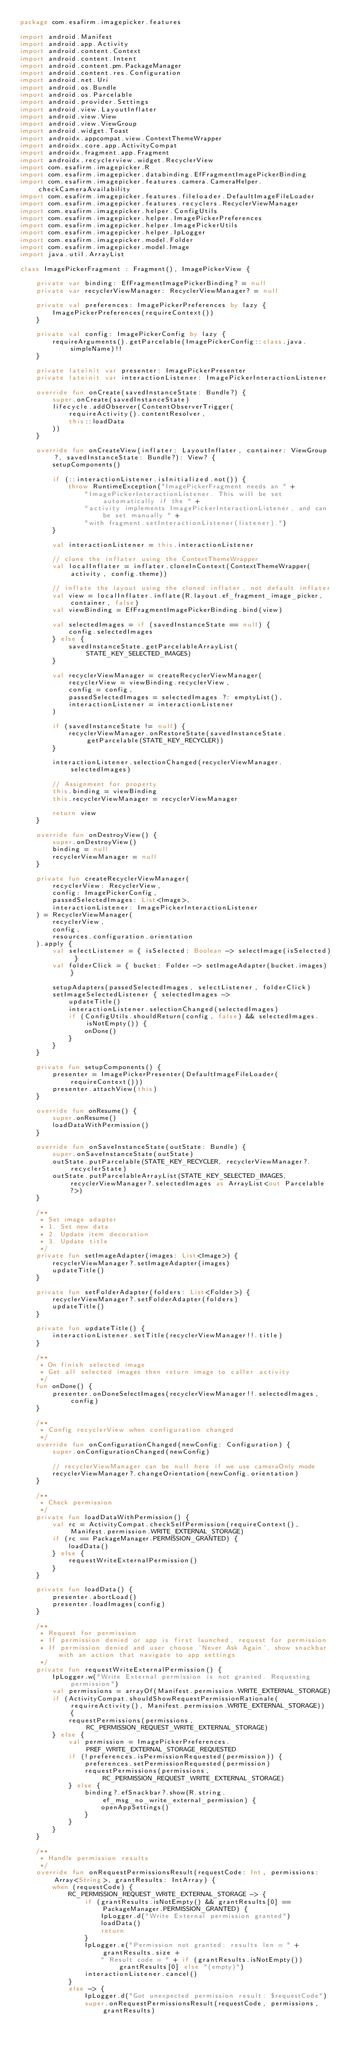<code> <loc_0><loc_0><loc_500><loc_500><_Kotlin_>package com.esafirm.imagepicker.features

import android.Manifest
import android.app.Activity
import android.content.Context
import android.content.Intent
import android.content.pm.PackageManager
import android.content.res.Configuration
import android.net.Uri
import android.os.Bundle
import android.os.Parcelable
import android.provider.Settings
import android.view.LayoutInflater
import android.view.View
import android.view.ViewGroup
import android.widget.Toast
import androidx.appcompat.view.ContextThemeWrapper
import androidx.core.app.ActivityCompat
import androidx.fragment.app.Fragment
import androidx.recyclerview.widget.RecyclerView
import com.esafirm.imagepicker.R
import com.esafirm.imagepicker.databinding.EfFragmentImagePickerBinding
import com.esafirm.imagepicker.features.camera.CameraHelper.checkCameraAvailability
import com.esafirm.imagepicker.features.fileloader.DefaultImageFileLoader
import com.esafirm.imagepicker.features.recyclers.RecyclerViewManager
import com.esafirm.imagepicker.helper.ConfigUtils
import com.esafirm.imagepicker.helper.ImagePickerPreferences
import com.esafirm.imagepicker.helper.ImagePickerUtils
import com.esafirm.imagepicker.helper.IpLogger
import com.esafirm.imagepicker.model.Folder
import com.esafirm.imagepicker.model.Image
import java.util.ArrayList

class ImagePickerFragment : Fragment(), ImagePickerView {

    private var binding: EfFragmentImagePickerBinding? = null
    private var recyclerViewManager: RecyclerViewManager? = null

    private val preferences: ImagePickerPreferences by lazy {
        ImagePickerPreferences(requireContext())
    }

    private val config: ImagePickerConfig by lazy {
        requireArguments().getParcelable(ImagePickerConfig::class.java.simpleName)!!
    }

    private lateinit var presenter: ImagePickerPresenter
    private lateinit var interactionListener: ImagePickerInteractionListener

    override fun onCreate(savedInstanceState: Bundle?) {
        super.onCreate(savedInstanceState)
        lifecycle.addObserver(ContentObserverTrigger(
            requireActivity().contentResolver,
            this::loadData
        ))
    }

    override fun onCreateView(inflater: LayoutInflater, container: ViewGroup?, savedInstanceState: Bundle?): View? {
        setupComponents()

        if (::interactionListener.isInitialized.not()) {
            throw RuntimeException("ImagePickerFragment needs an " +
                "ImagePickerInteractionListener. This will be set automatically if the " +
                "activity implements ImagePickerInteractionListener, and can be set manually " +
                "with fragment.setInteractionListener(listener).")
        }

        val interactionListener = this.interactionListener

        // clone the inflater using the ContextThemeWrapper
        val localInflater = inflater.cloneInContext(ContextThemeWrapper(activity, config.theme))

        // inflate the layout using the cloned inflater, not default inflater
        val view = localInflater.inflate(R.layout.ef_fragment_image_picker, container, false)
        val viewBinding = EfFragmentImagePickerBinding.bind(view)

        val selectedImages = if (savedInstanceState == null) {
            config.selectedImages
        } else {
            savedInstanceState.getParcelableArrayList(STATE_KEY_SELECTED_IMAGES)
        }

        val recyclerViewManager = createRecyclerViewManager(
            recyclerView = viewBinding.recyclerView,
            config = config,
            passedSelectedImages = selectedImages ?: emptyList(),
            interactionListener = interactionListener
        )

        if (savedInstanceState != null) {
            recyclerViewManager.onRestoreState(savedInstanceState.getParcelable(STATE_KEY_RECYCLER))
        }

        interactionListener.selectionChanged(recyclerViewManager.selectedImages)

        // Assignment for property
        this.binding = viewBinding
        this.recyclerViewManager = recyclerViewManager

        return view
    }

    override fun onDestroyView() {
        super.onDestroyView()
        binding = null
        recyclerViewManager = null
    }

    private fun createRecyclerViewManager(
        recyclerView: RecyclerView,
        config: ImagePickerConfig,
        passedSelectedImages: List<Image>,
        interactionListener: ImagePickerInteractionListener
    ) = RecyclerViewManager(
        recyclerView,
        config,
        resources.configuration.orientation
    ).apply {
        val selectListener = { isSelected: Boolean -> selectImage(isSelected) }
        val folderClick = { bucket: Folder -> setImageAdapter(bucket.images) }

        setupAdapters(passedSelectedImages, selectListener, folderClick)
        setImageSelectedListener { selectedImages ->
            updateTitle()
            interactionListener.selectionChanged(selectedImages)
            if (ConfigUtils.shouldReturn(config, false) && selectedImages.isNotEmpty()) {
                onDone()
            }
        }
    }

    private fun setupComponents() {
        presenter = ImagePickerPresenter(DefaultImageFileLoader(requireContext()))
        presenter.attachView(this)
    }

    override fun onResume() {
        super.onResume()
        loadDataWithPermission()
    }

    override fun onSaveInstanceState(outState: Bundle) {
        super.onSaveInstanceState(outState)
        outState.putParcelable(STATE_KEY_RECYCLER, recyclerViewManager?.recyclerState)
        outState.putParcelableArrayList(STATE_KEY_SELECTED_IMAGES, recyclerViewManager?.selectedImages as ArrayList<out Parcelable?>)
    }

    /**
     * Set image adapter
     * 1. Set new data
     * 2. Update item decoration
     * 3. Update title
     */
    private fun setImageAdapter(images: List<Image>) {
        recyclerViewManager?.setImageAdapter(images)
        updateTitle()
    }

    private fun setFolderAdapter(folders: List<Folder>) {
        recyclerViewManager?.setFolderAdapter(folders)
        updateTitle()
    }

    private fun updateTitle() {
        interactionListener.setTitle(recyclerViewManager!!.title)
    }

    /**
     * On finish selected image
     * Get all selected images then return image to caller activity
     */
    fun onDone() {
        presenter.onDoneSelectImages(recyclerViewManager!!.selectedImages, config)
    }

    /**
     * Config recyclerView when configuration changed
     */
    override fun onConfigurationChanged(newConfig: Configuration) {
        super.onConfigurationChanged(newConfig)

        // recyclerViewManager can be null here if we use cameraOnly mode
        recyclerViewManager?.changeOrientation(newConfig.orientation)
    }

    /**
     * Check permission
     */
    private fun loadDataWithPermission() {
        val rc = ActivityCompat.checkSelfPermission(requireContext(), Manifest.permission.WRITE_EXTERNAL_STORAGE)
        if (rc == PackageManager.PERMISSION_GRANTED) {
            loadData()
        } else {
            requestWriteExternalPermission()
        }
    }

    private fun loadData() {
        presenter.abortLoad()
        presenter.loadImages(config)
    }

    /**
     * Request for permission
     * If permission denied or app is first launched, request for permission
     * If permission denied and user choose 'Never Ask Again', show snackbar with an action that navigate to app settings
     */
    private fun requestWriteExternalPermission() {
        IpLogger.w("Write External permission is not granted. Requesting permission")
        val permissions = arrayOf(Manifest.permission.WRITE_EXTERNAL_STORAGE)
        if (ActivityCompat.shouldShowRequestPermissionRationale(requireActivity(), Manifest.permission.WRITE_EXTERNAL_STORAGE)) {
            requestPermissions(permissions, RC_PERMISSION_REQUEST_WRITE_EXTERNAL_STORAGE)
        } else {
            val permission = ImagePickerPreferences.PREF_WRITE_EXTERNAL_STORAGE_REQUESTED
            if (!preferences.isPermissionRequested(permission)) {
                preferences.setPermissionRequested(permission)
                requestPermissions(permissions, RC_PERMISSION_REQUEST_WRITE_EXTERNAL_STORAGE)
            } else {
                binding?.efSnackbar?.show(R.string.ef_msg_no_write_external_permission) {
                    openAppSettings()
                }
            }
        }
    }

    /**
     * Handle permission results
     */
    override fun onRequestPermissionsResult(requestCode: Int, permissions: Array<String>, grantResults: IntArray) {
        when (requestCode) {
            RC_PERMISSION_REQUEST_WRITE_EXTERNAL_STORAGE -> {
                if (grantResults.isNotEmpty() && grantResults[0] == PackageManager.PERMISSION_GRANTED) {
                    IpLogger.d("Write External permission granted")
                    loadData()
                    return
                }
                IpLogger.e("Permission not granted: results len = " + grantResults.size +
                    " Result code = " + if (grantResults.isNotEmpty()) grantResults[0] else "(empty)")
                interactionListener.cancel()
            }
            else -> {
                IpLogger.d("Got unexpected permission result: $requestCode")
                super.onRequestPermissionsResult(requestCode, permissions, grantResults)</code> 